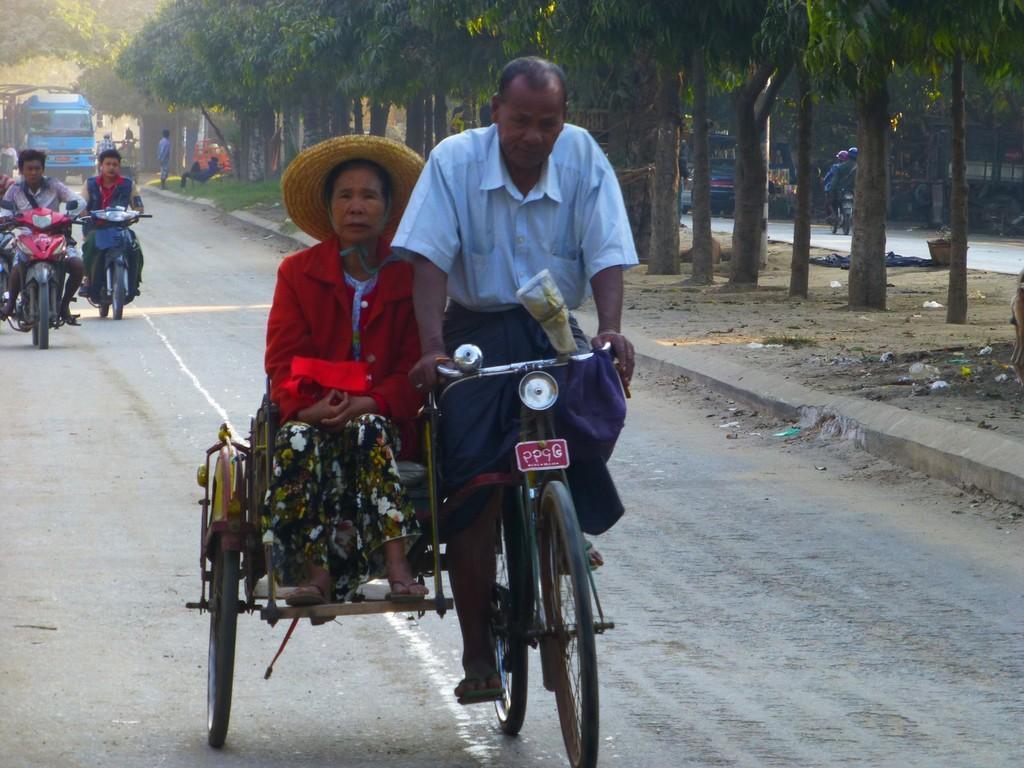Can you describe this image briefly? a person is riding a rickshaw and a woman is sitting on that. behind them there are other vehicles on the road. at the right there are many trees. 